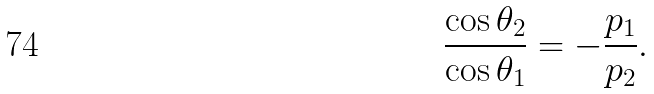Convert formula to latex. <formula><loc_0><loc_0><loc_500><loc_500>\frac { \cos \theta _ { 2 } } { \cos \theta _ { 1 } } = - \frac { { p } _ { 1 } } { { p } _ { 2 } } .</formula> 